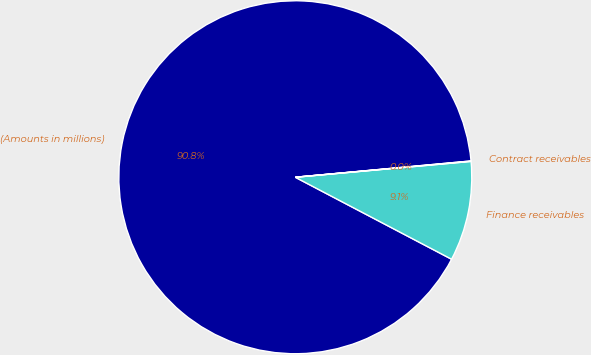Convert chart. <chart><loc_0><loc_0><loc_500><loc_500><pie_chart><fcel>(Amounts in millions)<fcel>Finance receivables<fcel>Contract receivables<nl><fcel>90.84%<fcel>9.12%<fcel>0.04%<nl></chart> 